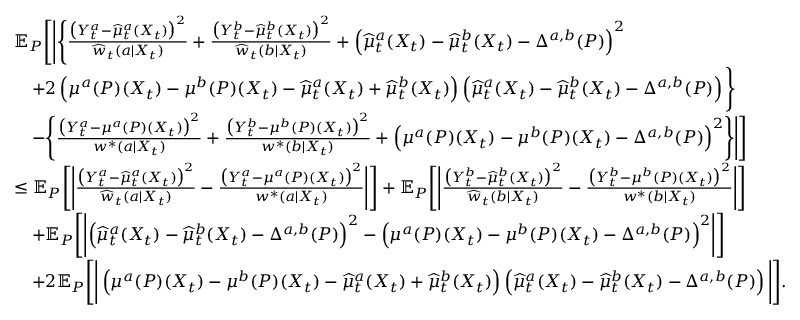Convert formula to latex. <formula><loc_0><loc_0><loc_500><loc_500>\begin{array} { r l } & { \mathbb { E } _ { P } \left [ \left | \left \{ \frac { \left ( Y _ { t } ^ { a } - \widehat { \mu } _ { t } ^ { a } ( X _ { t } ) \right ) ^ { 2 } } { \widehat { w } _ { t } ( a | X _ { t } ) } + \frac { \left ( Y _ { t } ^ { b } - \widehat { \mu } _ { t } ^ { b } ( X _ { t } ) \right ) ^ { 2 } } { \widehat { w } _ { t } ( b | X _ { t } ) } + \left ( \widehat { \mu } _ { t } ^ { a } ( X _ { t } ) - \widehat { \mu } _ { t } ^ { b } ( X _ { t } ) - \Delta ^ { a , b } ( P ) \right ) ^ { 2 } } \\ & { \quad + 2 \left ( \mu ^ { a } ( P ) ( X _ { t } ) - \mu ^ { b } ( P ) ( X _ { t } ) - \widehat { \mu } _ { t } ^ { a } ( X _ { t } ) + \widehat { \mu } _ { t } ^ { b } ( X _ { t } ) \right ) \left ( \widehat { \mu } _ { t } ^ { a } ( X _ { t } ) - \widehat { \mu } _ { t } ^ { b } ( X _ { t } ) - \Delta ^ { a , b } ( P ) \right ) \right \} } \\ & { \quad - \left \{ \frac { \left ( Y _ { t } ^ { a } - \mu ^ { a } ( P ) ( X _ { t } ) \right ) ^ { 2 } } { w ^ { * } ( a | X _ { t } ) } + \frac { \left ( Y _ { t } ^ { b } - \mu ^ { b } ( P ) ( X _ { t } ) \right ) ^ { 2 } } { w ^ { * } ( b | X _ { t } ) } + \left ( \mu ^ { a } ( P ) ( X _ { t } ) - \mu ^ { b } ( P ) ( X _ { t } ) - \Delta ^ { a , b } ( P ) \right ) ^ { 2 } \right \} \right | \right ] } \\ & { \leq \mathbb { E } _ { P } \left [ \left | \frac { \left ( Y _ { t } ^ { a } - \widehat { \mu } _ { t } ^ { a } ( X _ { t } ) \right ) ^ { 2 } } { \widehat { w } _ { t } ( a | X _ { t } ) } - \frac { \left ( Y _ { t } ^ { a } - \mu ^ { a } ( P ) ( X _ { t } ) \right ) ^ { 2 } } { w ^ { * } ( a | X _ { t } ) } \right | \right ] + \mathbb { E } _ { P } \left [ \left | \frac { \left ( Y _ { t } ^ { b } - \widehat { \mu } _ { t } ^ { b } ( X _ { t } ) \right ) ^ { 2 } } { \widehat { w } _ { t } ( b | X _ { t } ) } - \frac { \left ( Y _ { t } ^ { b } - \mu ^ { b } ( P ) ( X _ { t } ) \right ) ^ { 2 } } { w ^ { * } ( b | X _ { t } ) } \right | \right ] } \\ & { \quad + \mathbb { E } _ { P } \left [ \left | \left ( \widehat { \mu } _ { t } ^ { a } ( X _ { t } ) - \widehat { \mu } _ { t } ^ { b } ( X _ { t } ) - \Delta ^ { a , b } ( P ) \right ) ^ { 2 } - \left ( \mu ^ { a } ( P ) ( X _ { t } ) - \mu ^ { b } ( P ) ( X _ { t } ) - \Delta ^ { a , b } ( P ) \right ) ^ { 2 } \right | \right ] } \\ & { \quad + 2 \mathbb { E } _ { P } \left [ \left | \left ( \mu ^ { a } ( P ) ( X _ { t } ) - \mu ^ { b } ( P ) ( X _ { t } ) - \widehat { \mu } _ { t } ^ { a } ( X _ { t } ) + \widehat { \mu } _ { t } ^ { b } ( X _ { t } ) \right ) \left ( \widehat { \mu } _ { t } ^ { a } ( X _ { t } ) - \widehat { \mu } _ { t } ^ { b } ( X _ { t } ) - \Delta ^ { a , b } ( P ) \right ) \right | \right ] . } \end{array}</formula> 